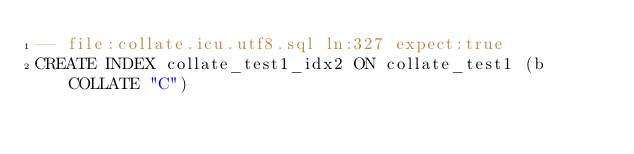Convert code to text. <code><loc_0><loc_0><loc_500><loc_500><_SQL_>-- file:collate.icu.utf8.sql ln:327 expect:true
CREATE INDEX collate_test1_idx2 ON collate_test1 (b COLLATE "C")
</code> 